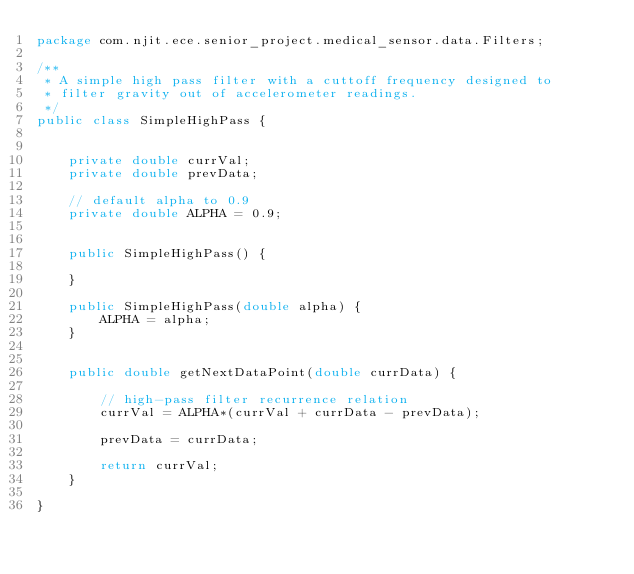<code> <loc_0><loc_0><loc_500><loc_500><_Java_>package com.njit.ece.senior_project.medical_sensor.data.Filters;

/**
 * A simple high pass filter with a cuttoff frequency designed to
 * filter gravity out of accelerometer readings.
 */
public class SimpleHighPass {


    private double currVal;
    private double prevData;

    // default alpha to 0.9
    private double ALPHA = 0.9;


    public SimpleHighPass() {

    }

    public SimpleHighPass(double alpha) {
        ALPHA = alpha;
    }


    public double getNextDataPoint(double currData) {

        // high-pass filter recurrence relation
        currVal = ALPHA*(currVal + currData - prevData);

        prevData = currData;

        return currVal;
    }

}</code> 